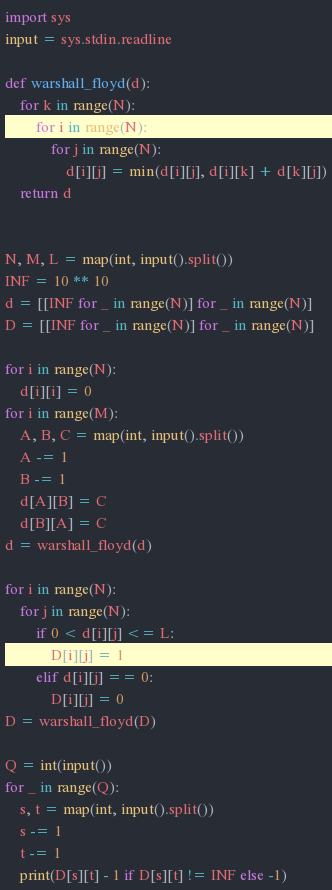<code> <loc_0><loc_0><loc_500><loc_500><_Python_>import sys
input = sys.stdin.readline

def warshall_floyd(d):
    for k in range(N):
        for i in range(N):
            for j in range(N):
                d[i][j] = min(d[i][j], d[i][k] + d[k][j])
    return d


N, M, L = map(int, input().split())
INF = 10 ** 10
d = [[INF for _ in range(N)] for _ in range(N)]
D = [[INF for _ in range(N)] for _ in range(N)]

for i in range(N):
    d[i][i] = 0
for i in range(M):
    A, B, C = map(int, input().split())
    A -= 1
    B -= 1
    d[A][B] = C
    d[B][A] = C
d = warshall_floyd(d)

for i in range(N):
    for j in range(N):
        if 0 < d[i][j] <= L:
            D[i][j] = 1
        elif d[i][j] == 0:
            D[i][j] = 0
D = warshall_floyd(D)

Q = int(input())
for _ in range(Q):
    s, t = map(int, input().split())
    s -= 1
    t -= 1
    print(D[s][t] - 1 if D[s][t] != INF else -1)
</code> 